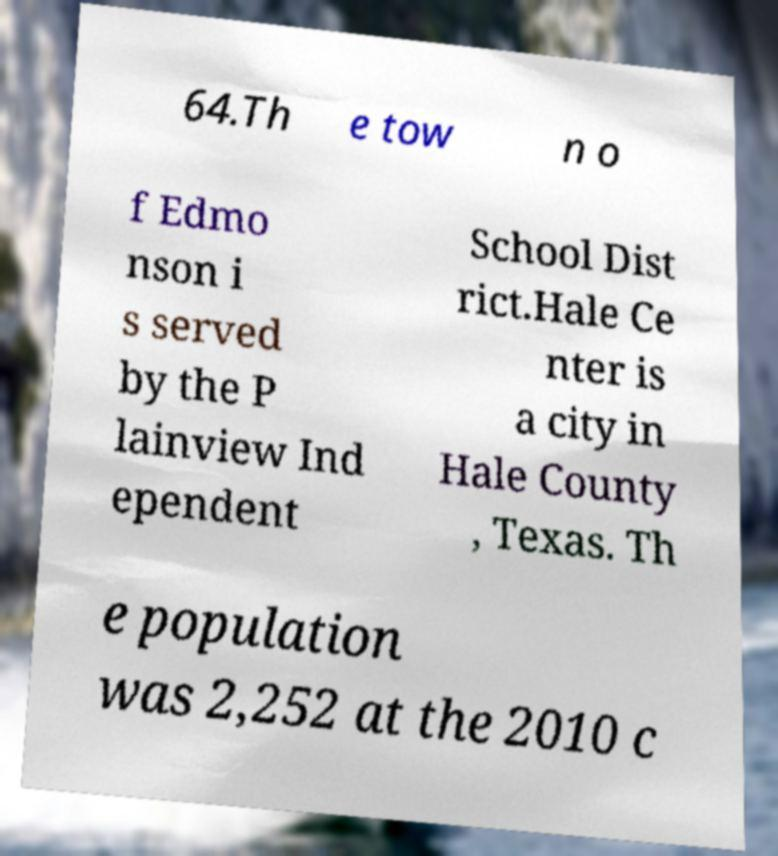Could you assist in decoding the text presented in this image and type it out clearly? 64.Th e tow n o f Edmo nson i s served by the P lainview Ind ependent School Dist rict.Hale Ce nter is a city in Hale County , Texas. Th e population was 2,252 at the 2010 c 